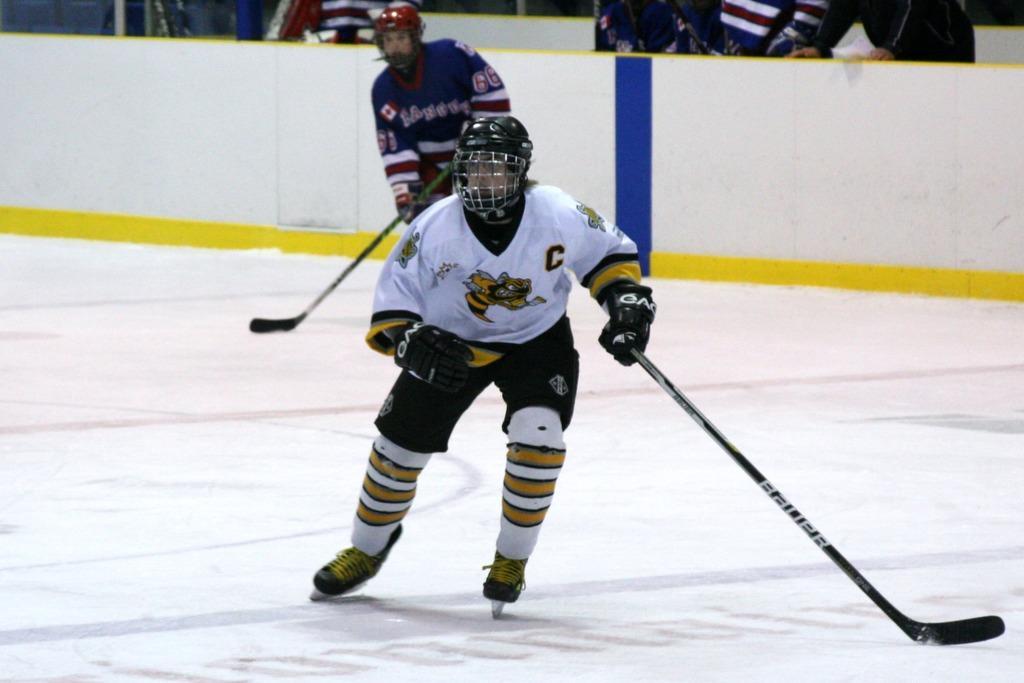Please provide a concise description of this image. In this picture there are two people holding hockey sticks and wore helmets and gloves. We can see wall. In the background of the image we can see people. 